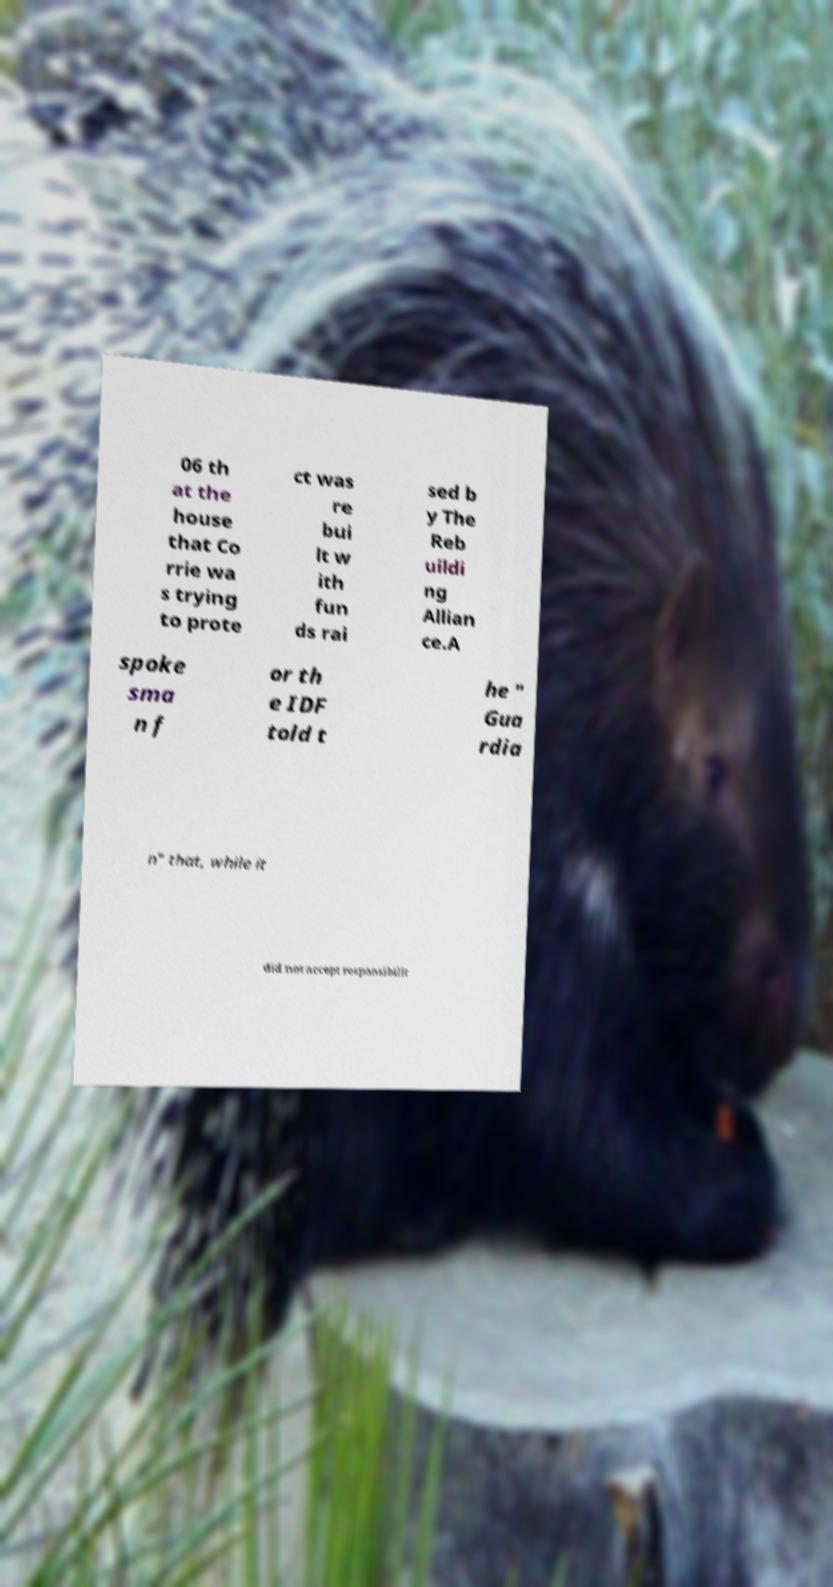Please identify and transcribe the text found in this image. 06 th at the house that Co rrie wa s trying to prote ct was re bui lt w ith fun ds rai sed b y The Reb uildi ng Allian ce.A spoke sma n f or th e IDF told t he " Gua rdia n" that, while it did not accept responsibilit 